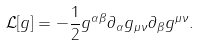<formula> <loc_0><loc_0><loc_500><loc_500>\mathcal { L } [ g ] = - \frac { 1 } { 2 } g ^ { \alpha \beta } \partial _ { \alpha } g _ { \mu \nu } \partial _ { \beta } g ^ { \mu \nu } .</formula> 